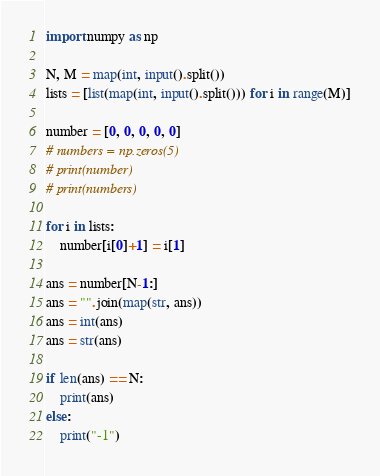<code> <loc_0><loc_0><loc_500><loc_500><_Python_>import numpy as np

N, M = map(int, input().split())
lists = [list(map(int, input().split())) for i in range(M)]

number = [0, 0, 0, 0, 0]
# numbers = np.zeros(5)
# print(number)
# print(numbers)

for i in lists:
    number[i[0]+1] = i[1]

ans = number[N-1:]
ans = "".join(map(str, ans))
ans = int(ans)
ans = str(ans)

if len(ans) == N:
    print(ans)
else:
    print("-1")</code> 